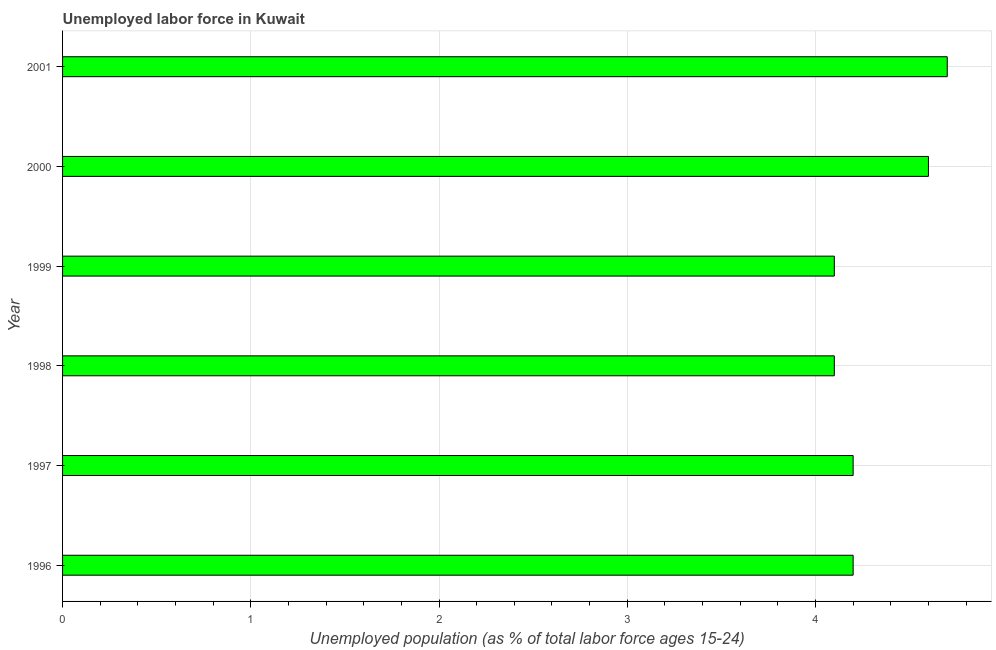Does the graph contain grids?
Your answer should be compact. Yes. What is the title of the graph?
Offer a very short reply. Unemployed labor force in Kuwait. What is the label or title of the X-axis?
Provide a short and direct response. Unemployed population (as % of total labor force ages 15-24). What is the total unemployed youth population in 1997?
Provide a short and direct response. 4.2. Across all years, what is the maximum total unemployed youth population?
Give a very brief answer. 4.7. Across all years, what is the minimum total unemployed youth population?
Your answer should be very brief. 4.1. In which year was the total unemployed youth population minimum?
Provide a short and direct response. 1998. What is the sum of the total unemployed youth population?
Keep it short and to the point. 25.9. What is the average total unemployed youth population per year?
Provide a succinct answer. 4.32. What is the median total unemployed youth population?
Provide a short and direct response. 4.2. In how many years, is the total unemployed youth population greater than 1.8 %?
Keep it short and to the point. 6. What is the ratio of the total unemployed youth population in 1996 to that in 1999?
Offer a terse response. 1.02. Is the total unemployed youth population in 1999 less than that in 2001?
Your response must be concise. Yes. Is the difference between the total unemployed youth population in 1998 and 2001 greater than the difference between any two years?
Your answer should be compact. Yes. What is the difference between the highest and the second highest total unemployed youth population?
Ensure brevity in your answer.  0.1. Is the sum of the total unemployed youth population in 1997 and 2000 greater than the maximum total unemployed youth population across all years?
Make the answer very short. Yes. What is the difference between the highest and the lowest total unemployed youth population?
Offer a terse response. 0.6. How many years are there in the graph?
Ensure brevity in your answer.  6. Are the values on the major ticks of X-axis written in scientific E-notation?
Provide a short and direct response. No. What is the Unemployed population (as % of total labor force ages 15-24) in 1996?
Provide a short and direct response. 4.2. What is the Unemployed population (as % of total labor force ages 15-24) in 1997?
Give a very brief answer. 4.2. What is the Unemployed population (as % of total labor force ages 15-24) of 1998?
Give a very brief answer. 4.1. What is the Unemployed population (as % of total labor force ages 15-24) in 1999?
Provide a short and direct response. 4.1. What is the Unemployed population (as % of total labor force ages 15-24) of 2000?
Ensure brevity in your answer.  4.6. What is the Unemployed population (as % of total labor force ages 15-24) of 2001?
Ensure brevity in your answer.  4.7. What is the difference between the Unemployed population (as % of total labor force ages 15-24) in 1996 and 2000?
Your answer should be compact. -0.4. What is the difference between the Unemployed population (as % of total labor force ages 15-24) in 1996 and 2001?
Provide a short and direct response. -0.5. What is the difference between the Unemployed population (as % of total labor force ages 15-24) in 1997 and 1999?
Provide a short and direct response. 0.1. What is the difference between the Unemployed population (as % of total labor force ages 15-24) in 1997 and 2000?
Provide a short and direct response. -0.4. What is the difference between the Unemployed population (as % of total labor force ages 15-24) in 1998 and 1999?
Ensure brevity in your answer.  0. What is the difference between the Unemployed population (as % of total labor force ages 15-24) in 1998 and 2000?
Offer a very short reply. -0.5. What is the difference between the Unemployed population (as % of total labor force ages 15-24) in 1998 and 2001?
Offer a terse response. -0.6. What is the difference between the Unemployed population (as % of total labor force ages 15-24) in 1999 and 2000?
Make the answer very short. -0.5. What is the difference between the Unemployed population (as % of total labor force ages 15-24) in 1999 and 2001?
Provide a succinct answer. -0.6. What is the difference between the Unemployed population (as % of total labor force ages 15-24) in 2000 and 2001?
Make the answer very short. -0.1. What is the ratio of the Unemployed population (as % of total labor force ages 15-24) in 1996 to that in 1997?
Your response must be concise. 1. What is the ratio of the Unemployed population (as % of total labor force ages 15-24) in 1996 to that in 1999?
Ensure brevity in your answer.  1.02. What is the ratio of the Unemployed population (as % of total labor force ages 15-24) in 1996 to that in 2000?
Offer a terse response. 0.91. What is the ratio of the Unemployed population (as % of total labor force ages 15-24) in 1996 to that in 2001?
Make the answer very short. 0.89. What is the ratio of the Unemployed population (as % of total labor force ages 15-24) in 1997 to that in 1998?
Your response must be concise. 1.02. What is the ratio of the Unemployed population (as % of total labor force ages 15-24) in 1997 to that in 2000?
Your response must be concise. 0.91. What is the ratio of the Unemployed population (as % of total labor force ages 15-24) in 1997 to that in 2001?
Offer a terse response. 0.89. What is the ratio of the Unemployed population (as % of total labor force ages 15-24) in 1998 to that in 2000?
Keep it short and to the point. 0.89. What is the ratio of the Unemployed population (as % of total labor force ages 15-24) in 1998 to that in 2001?
Offer a terse response. 0.87. What is the ratio of the Unemployed population (as % of total labor force ages 15-24) in 1999 to that in 2000?
Provide a succinct answer. 0.89. What is the ratio of the Unemployed population (as % of total labor force ages 15-24) in 1999 to that in 2001?
Your answer should be compact. 0.87. What is the ratio of the Unemployed population (as % of total labor force ages 15-24) in 2000 to that in 2001?
Your response must be concise. 0.98. 